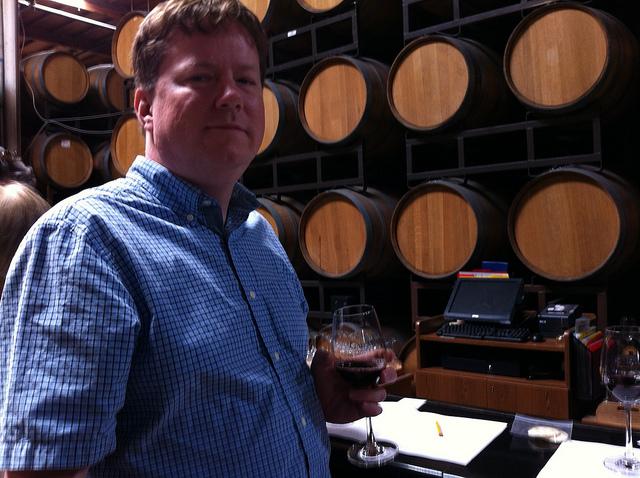What type of glass is the man holding?
Short answer required. Wine. This man is engaging in what activity?
Quick response, please. Wine tasting. Did the man pay for the drink?
Short answer required. Yes. 